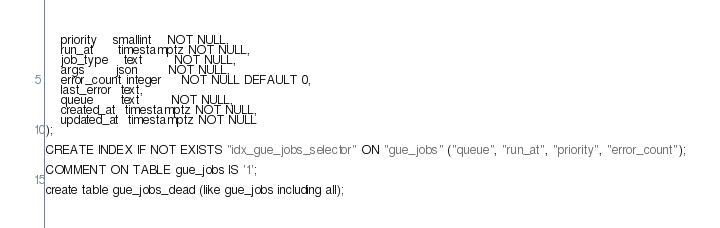Convert code to text. <code><loc_0><loc_0><loc_500><loc_500><_SQL_>    priority    smallint    NOT NULL,
    run_at      timestamptz NOT NULL,
    job_type    text        NOT NULL,
    args        json        NOT NULL,
    error_count integer     NOT NULL DEFAULT 0,
    last_error  text,
    queue       text        NOT NULL,
    created_at  timestamptz NOT NULL,
    updated_at  timestamptz NOT NULL
);

CREATE INDEX IF NOT EXISTS "idx_gue_jobs_selector" ON "gue_jobs" ("queue", "run_at", "priority", "error_count");

COMMENT ON TABLE gue_jobs IS '1';

create table gue_jobs_dead (like gue_jobs including all);
</code> 